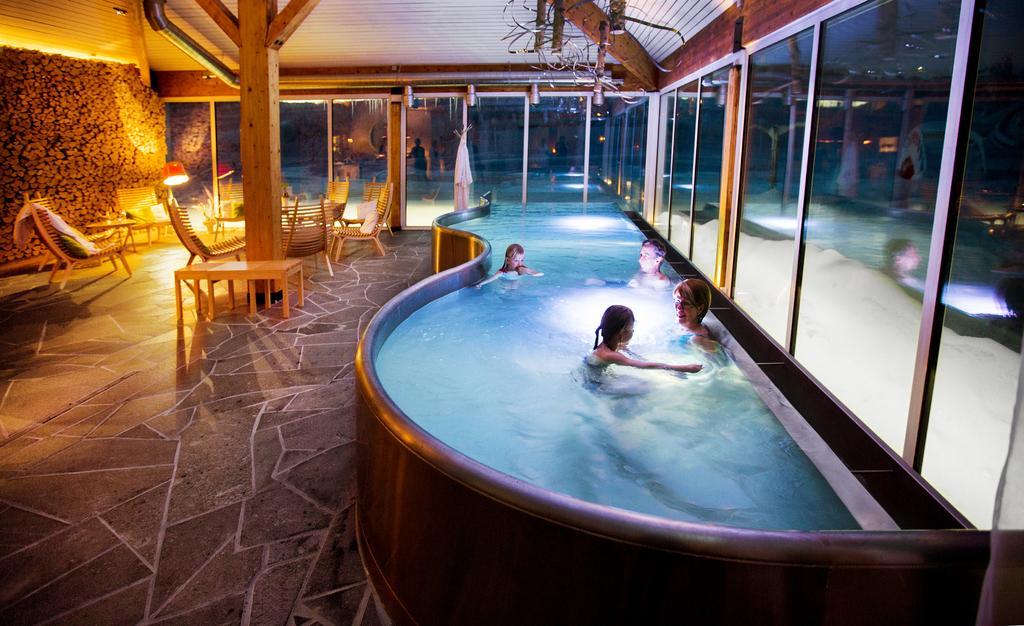How would you summarize this image in a sentence or two? In this image we can see men, women and children are swimming in the pool. Left side of the image, table and chairs are there. We can see one lamp also. At the top of the image roof is there which is in brown color. Background of the image the glass windows are there. We can see one wooden pole in the middle of the room. 